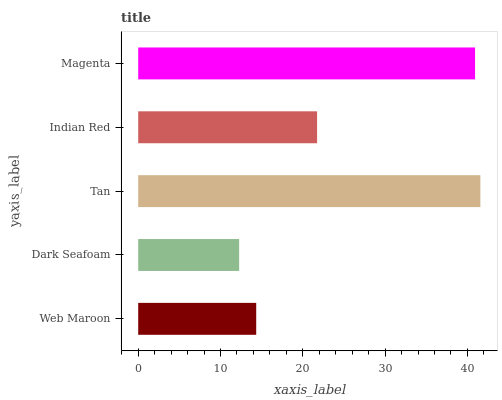Is Dark Seafoam the minimum?
Answer yes or no. Yes. Is Tan the maximum?
Answer yes or no. Yes. Is Tan the minimum?
Answer yes or no. No. Is Dark Seafoam the maximum?
Answer yes or no. No. Is Tan greater than Dark Seafoam?
Answer yes or no. Yes. Is Dark Seafoam less than Tan?
Answer yes or no. Yes. Is Dark Seafoam greater than Tan?
Answer yes or no. No. Is Tan less than Dark Seafoam?
Answer yes or no. No. Is Indian Red the high median?
Answer yes or no. Yes. Is Indian Red the low median?
Answer yes or no. Yes. Is Tan the high median?
Answer yes or no. No. Is Web Maroon the low median?
Answer yes or no. No. 